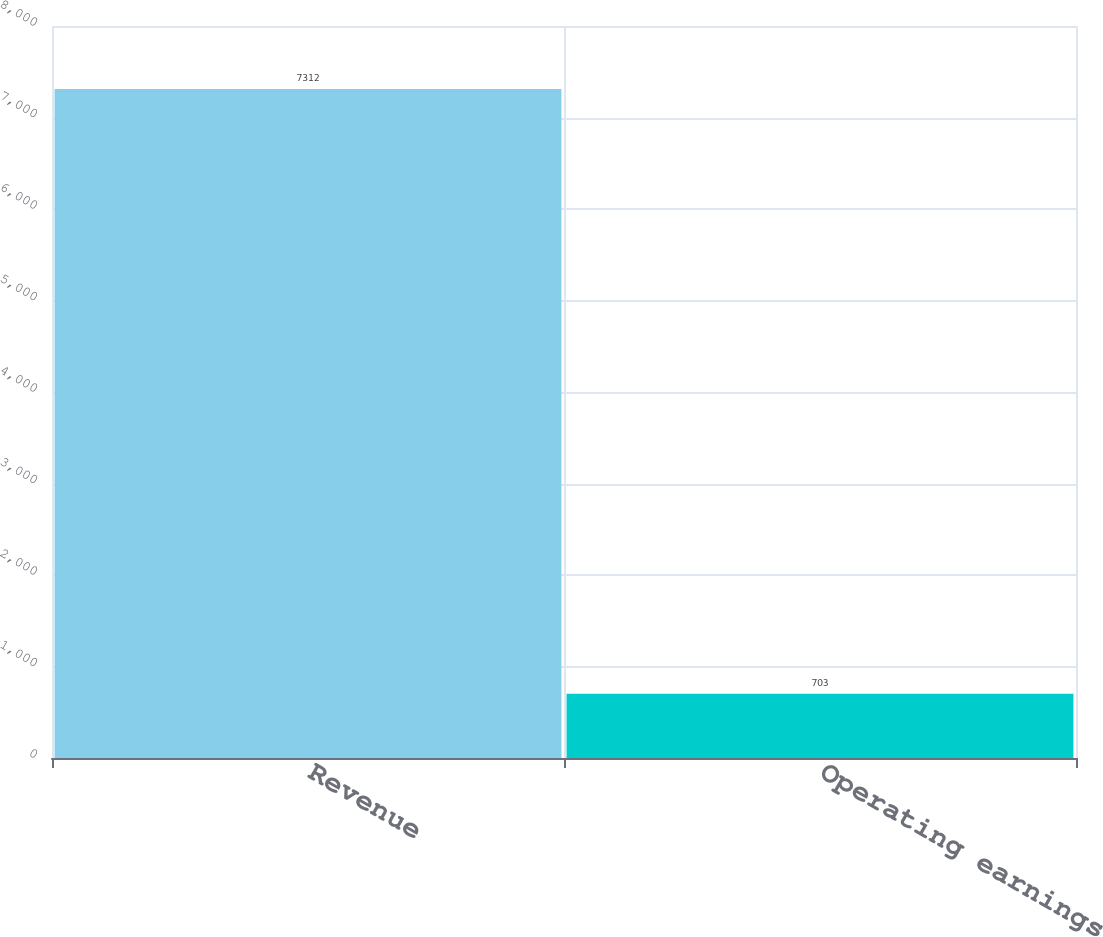Convert chart to OTSL. <chart><loc_0><loc_0><loc_500><loc_500><bar_chart><fcel>Revenue<fcel>Operating earnings<nl><fcel>7312<fcel>703<nl></chart> 